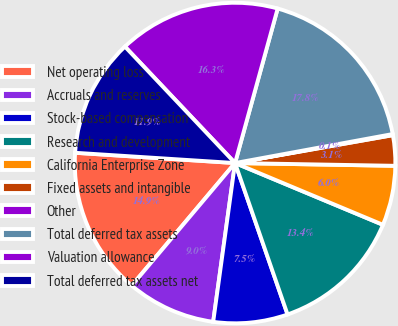Convert chart. <chart><loc_0><loc_0><loc_500><loc_500><pie_chart><fcel>Net operating loss<fcel>Accruals and reserves<fcel>Stock-based compensation<fcel>Research and development<fcel>California Enterprise Zone<fcel>Fixed assets and intangible<fcel>Other<fcel>Total deferred tax assets<fcel>Valuation allowance<fcel>Total deferred tax assets net<nl><fcel>14.87%<fcel>8.97%<fcel>7.49%<fcel>13.39%<fcel>6.02%<fcel>3.06%<fcel>0.11%<fcel>17.82%<fcel>16.34%<fcel>11.92%<nl></chart> 